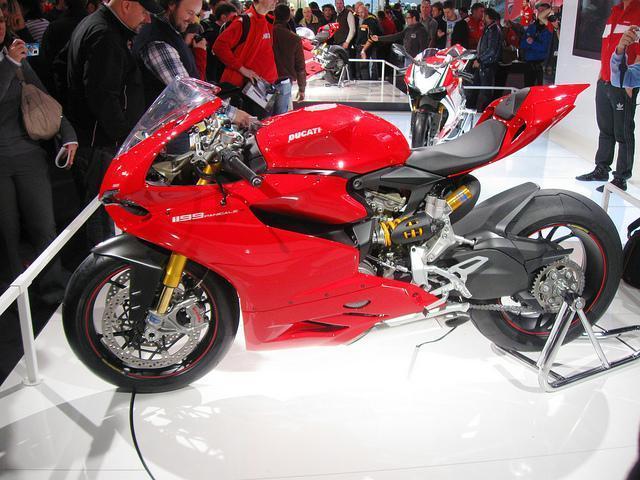How many wheels?
Give a very brief answer. 2. How many motorcycles can be seen?
Give a very brief answer. 3. How many people are there?
Give a very brief answer. 6. 